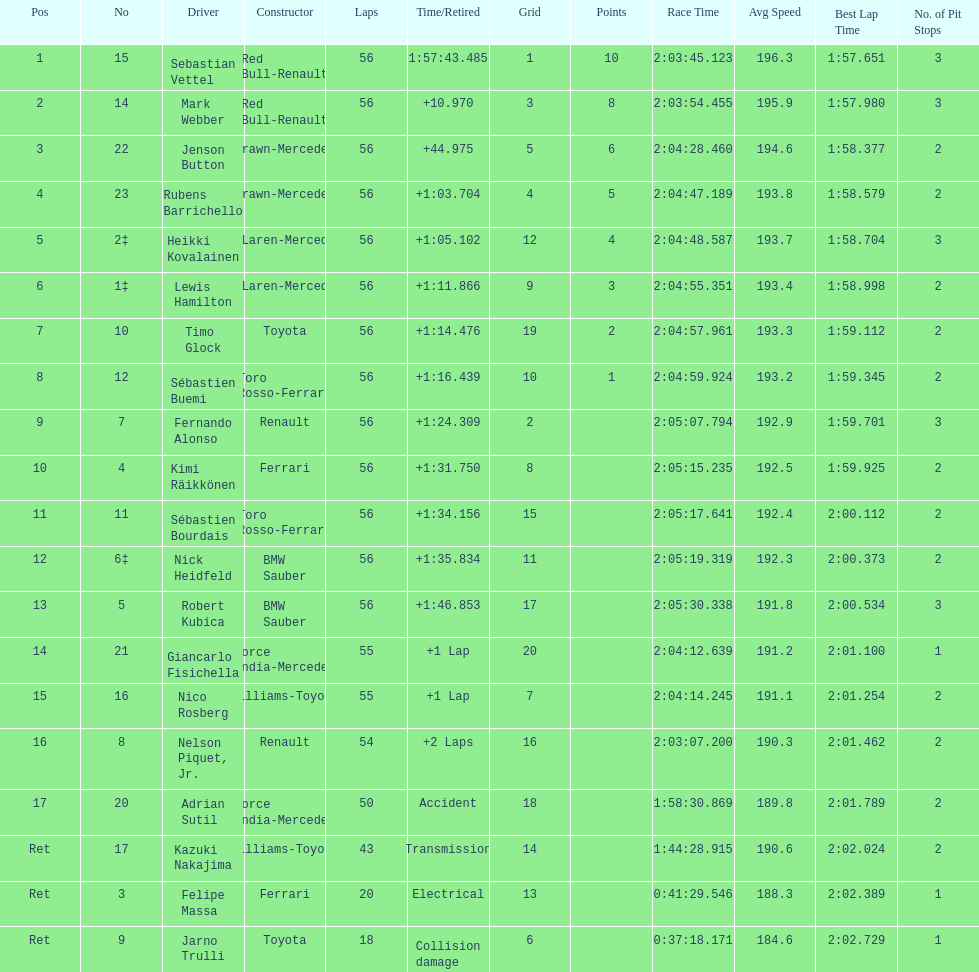What is the total number of drivers on the list? 20. 